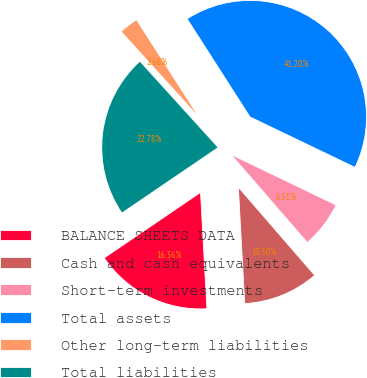Convert chart to OTSL. <chart><loc_0><loc_0><loc_500><loc_500><pie_chart><fcel>BALANCE SHEETS DATA<fcel>Cash and cash equivalents<fcel>Short-term investments<fcel>Total assets<fcel>Other long-term liabilities<fcel>Total liabilities<nl><fcel>16.36%<fcel>10.5%<fcel>6.51%<fcel>41.2%<fcel>2.66%<fcel>22.78%<nl></chart> 